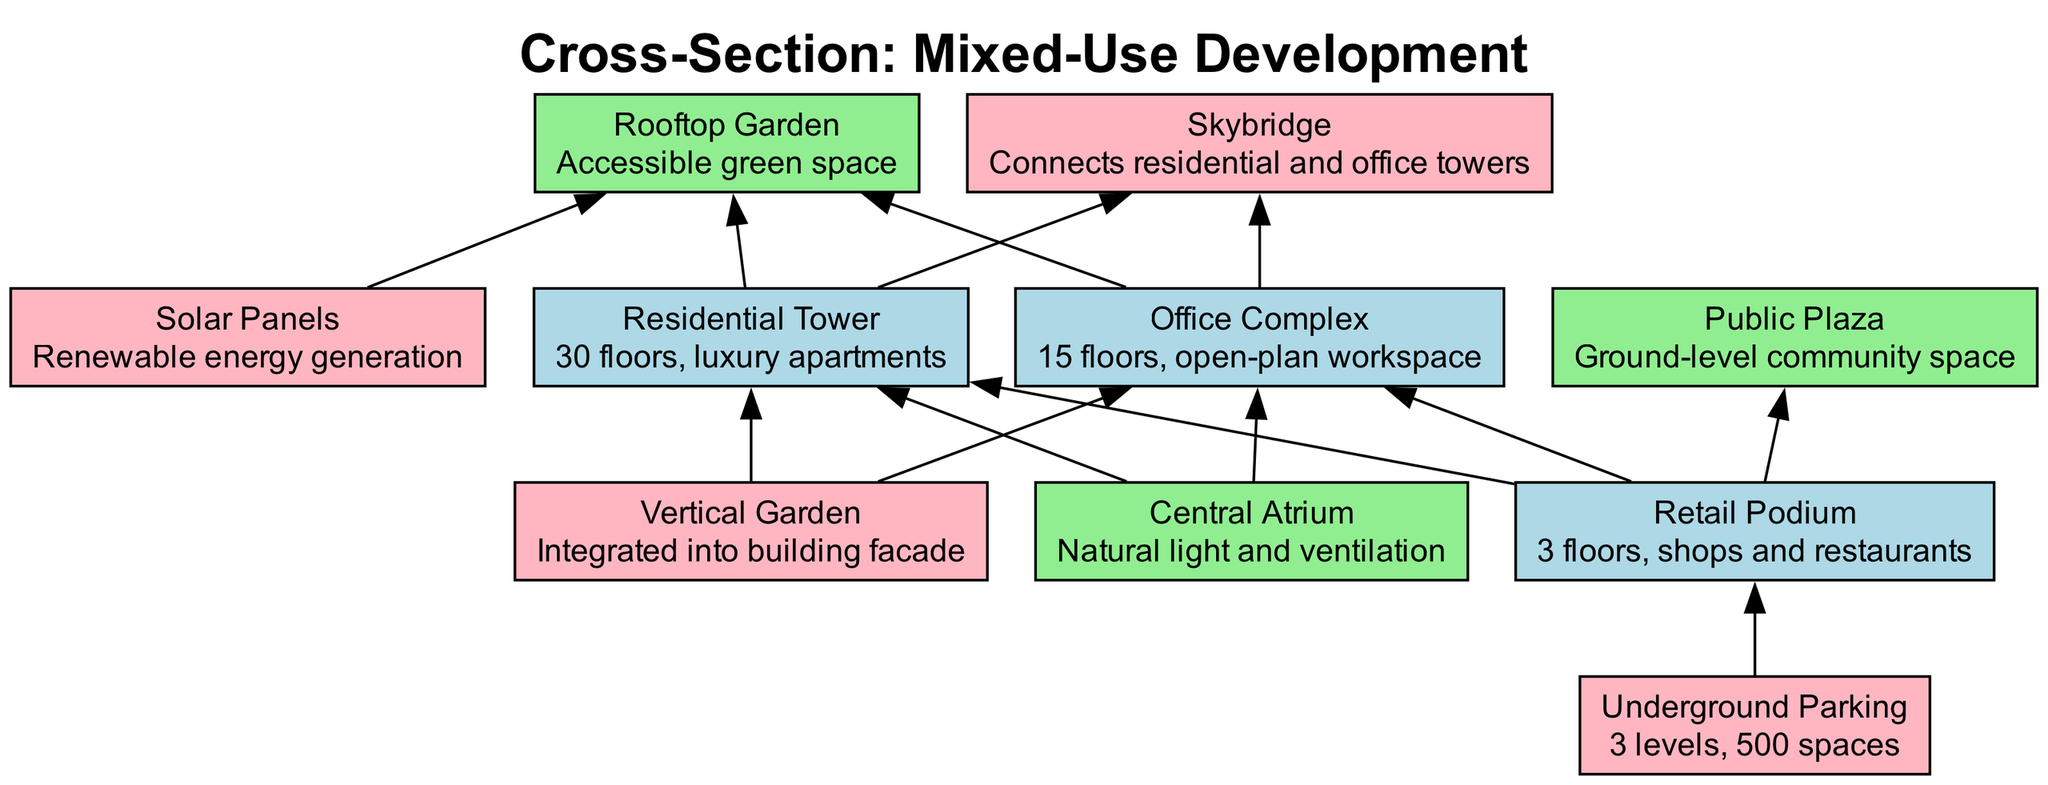What is the height of the Residential Tower? The diagram specifies that the Residential Tower has 30 floors, indicating its height in terms of the number of floors.
Answer: 30 floors How many floors does the Office Complex have? Looking at the diagram, it shows that the Office Complex consists of 15 floors.
Answer: 15 floors What type of space is the Rooftop Garden? The Rooftop Garden is categorized as a space in the diagram, designated for accessible green space.
Answer: Space Which feature connects the Residential and Office Towers? The diagram indicates that the Skybridge serves to connect the Residential and Office Towers.
Answer: Skybridge How many parking spaces are in the Underground Parking? The diagram clearly states that the Underground Parking has a total of 500 spaces.
Answer: 500 spaces Which spaces are directly associated with the Retail Podium? The diagram shows that the Retail Podium is directly connected to the Underground Parking, Office Complex, Residential Tower, and Public Plaza.
Answer: Underground Parking, Office Complex, Residential Tower, Public Plaza What is the purpose of the Central Atrium? The Central Atrium is noted in the diagram as providing natural light and ventilation, highlighting its functional purpose within the development.
Answer: Natural light and ventilation Which element is integrated into the building facade? The diagram specifies that the Vertical Garden is the feature integrated into the building facade.
Answer: Vertical Garden How many levels are designated for the Underground Parking? According to the diagram, the Underground Parking consists of three levels.
Answer: 3 levels 